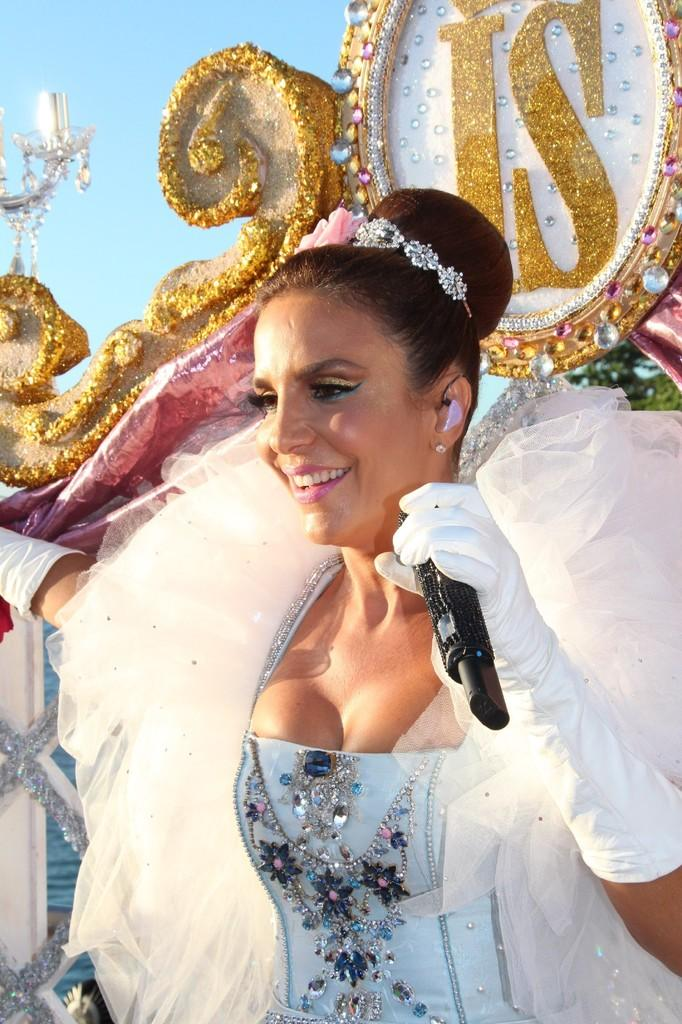Who is present in the image? There is a woman in the image. What is the woman doing in the image? The woman is standing in the image. What is the woman holding in her hand? The woman is holding a microphone in her hand. What is the woman wearing in the image? The woman is wearing a costume in the image. What can be seen in the background of the image? There is a design in the background of the image. What type of engine can be seen in the image? There is no engine present in the image. 